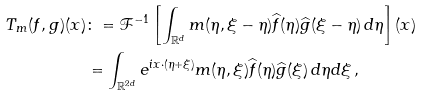<formula> <loc_0><loc_0><loc_500><loc_500>T _ { m } ( f , g ) ( x ) & \colon = \mathcal { F } ^ { - 1 } \left [ \int _ { \mathbb { R } ^ { d } } m ( \eta , \xi - \eta ) \widehat { f } ( \eta ) \widehat { g } ( \xi - \eta ) \, d \eta \right ] ( x ) \\ & = \int _ { \mathbb { R } ^ { 2 d } } e ^ { i x \cdot ( \eta + \xi ) } m ( \eta , \xi ) \widehat { f } ( \eta ) \widehat { g } ( \xi ) \, d \eta d \xi \, ,</formula> 